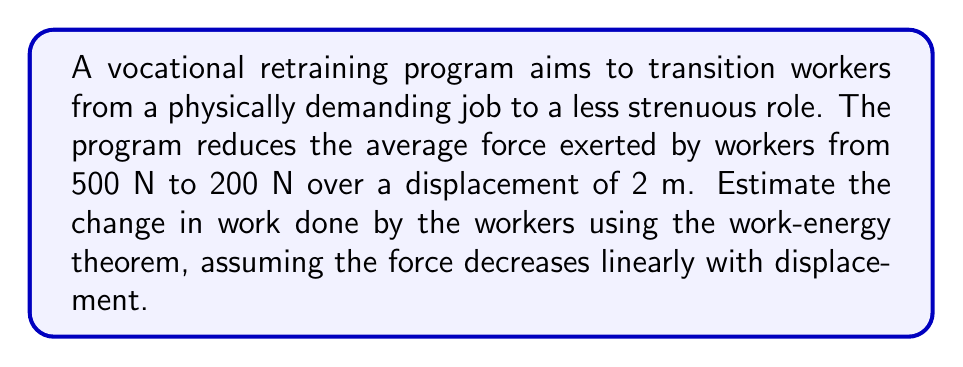Give your solution to this math problem. To solve this problem, we'll use the work-energy theorem and the concept of average force over a varying distance.

1) The work-energy theorem states that the work done on an object is equal to its change in kinetic energy:

   $$W = \Delta KE$$

2) In this case, we're interested in the change in work done by the workers. The work is calculated by the force applied over a distance:

   $$W = F \cdot d$$

3) Since the force is changing linearly from 500 N to 200 N, we can use the average force:

   $$F_{avg} = \frac{F_{initial} + F_{final}}{2} = \frac{500 N + 200 N}{2} = 350 N$$

4) Now we can calculate the work done:

   $$W = F_{avg} \cdot d = 350 N \cdot 2 m = 700 J$$

5) This represents the new amount of work done after retraining. To find the change in work, we need to calculate the initial work:

   $$W_{initial} = F_{initial} \cdot d = 500 N \cdot 2 m = 1000 J$$

6) The change in work is the difference between the initial and final work:

   $$\Delta W = W_{initial} - W_{final} = 1000 J - 700 J = 300 J$$

This positive change indicates a reduction in the work done by the workers, which aligns with the goal of transitioning to less strenuous roles.
Answer: 300 J 